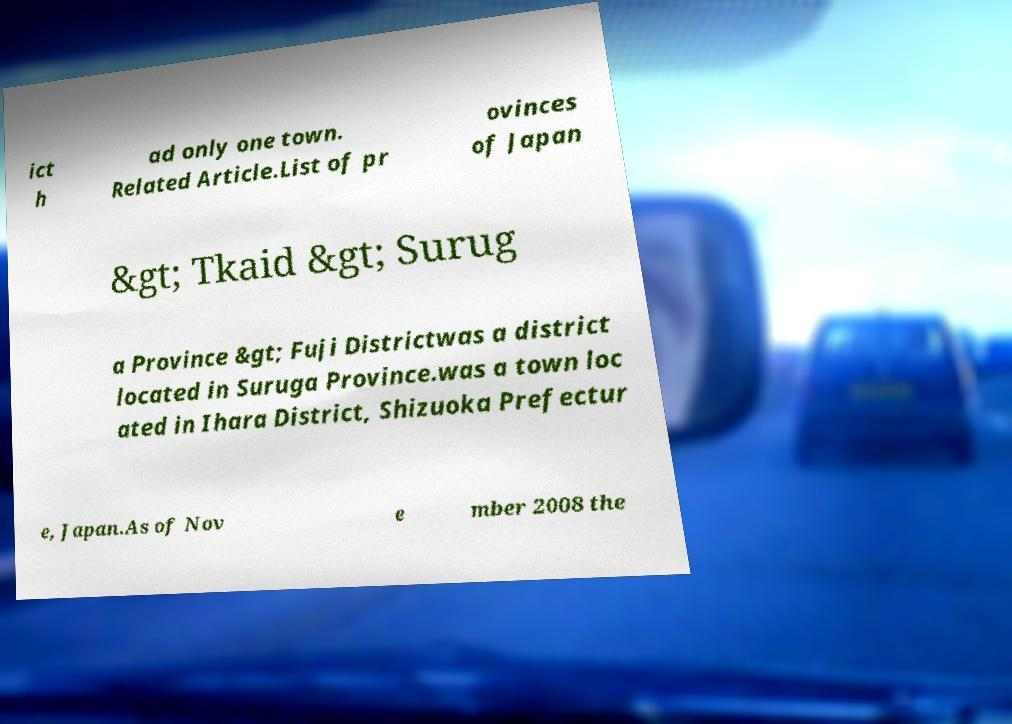I need the written content from this picture converted into text. Can you do that? ict h ad only one town. Related Article.List of pr ovinces of Japan &gt; Tkaid &gt; Surug a Province &gt; Fuji Districtwas a district located in Suruga Province.was a town loc ated in Ihara District, Shizuoka Prefectur e, Japan.As of Nov e mber 2008 the 